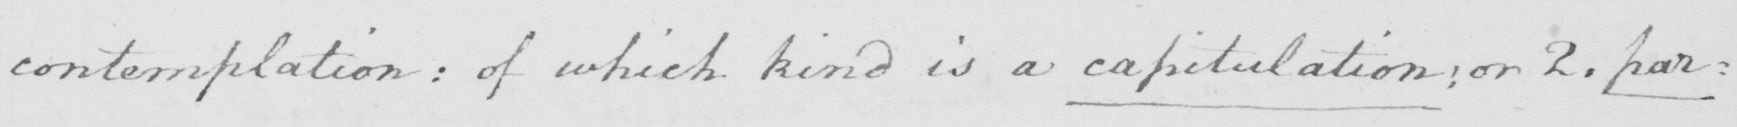What is written in this line of handwriting? contemplation :  of which kind is a capitulation :  or 2 . par= 